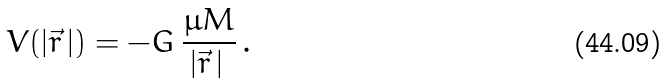Convert formula to latex. <formula><loc_0><loc_0><loc_500><loc_500>V ( | \vec { r } \, | ) = - G \, \frac { \mu M } { | \vec { r } \, | \, } \, .</formula> 